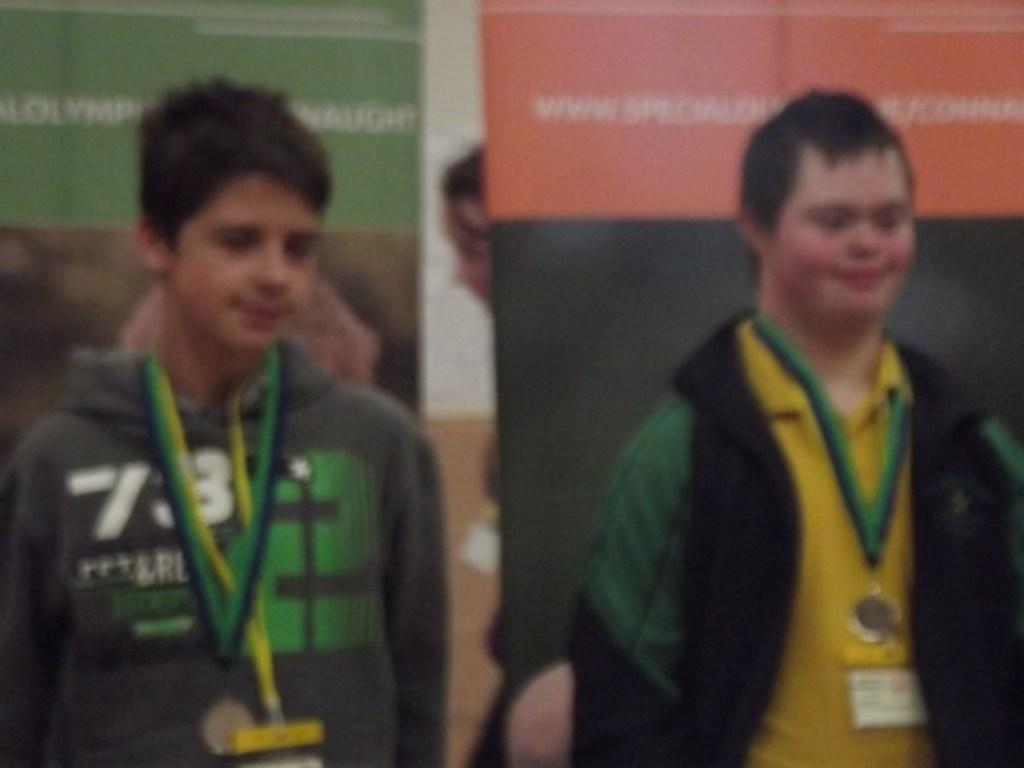What is the overall quality of the image? The image is blurred. What can be seen in the background of the image? There are boards visible in the background. Can you describe the person in the image? A partial part of a person is visible in the image. What are the men in the image wearing? The men in the image are wearing medals. What else are the men in the image wearing? Identification cards are worn by the men in the image. What type of fruit is hanging from the tail of the person in the image? There is no fruit or tail present in the image; it is blurred and only shows a partial part of a person. 